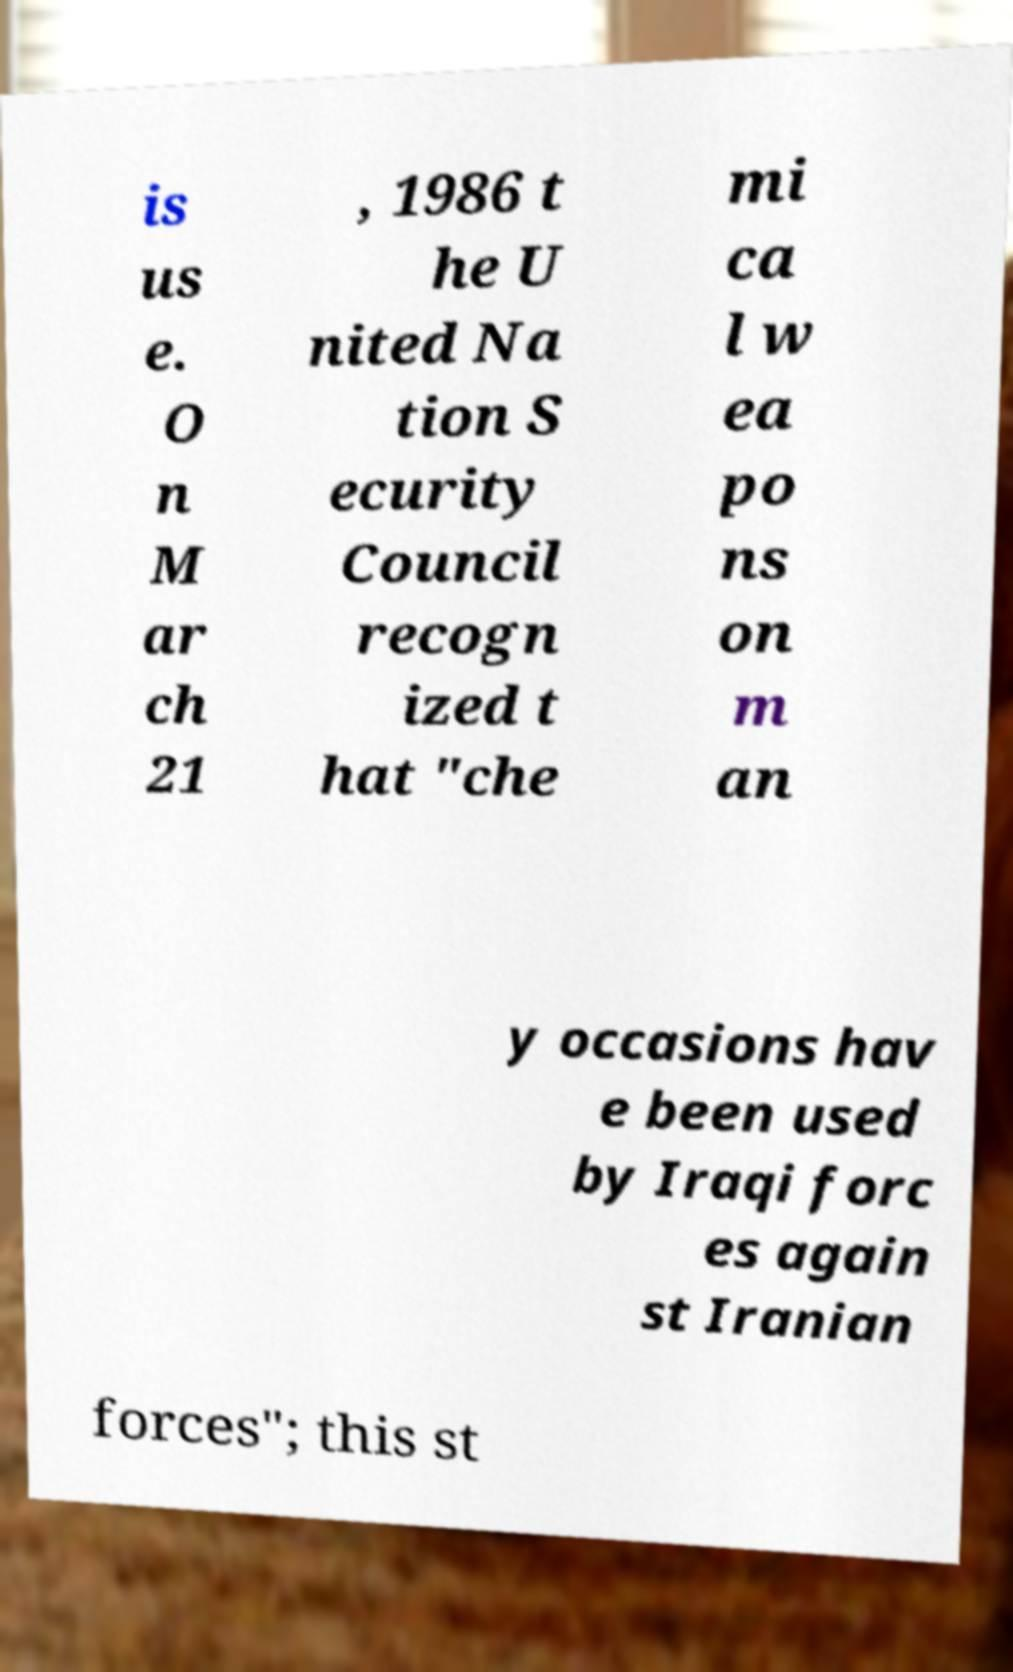Can you read and provide the text displayed in the image?This photo seems to have some interesting text. Can you extract and type it out for me? is us e. O n M ar ch 21 , 1986 t he U nited Na tion S ecurity Council recogn ized t hat "che mi ca l w ea po ns on m an y occasions hav e been used by Iraqi forc es again st Iranian forces"; this st 